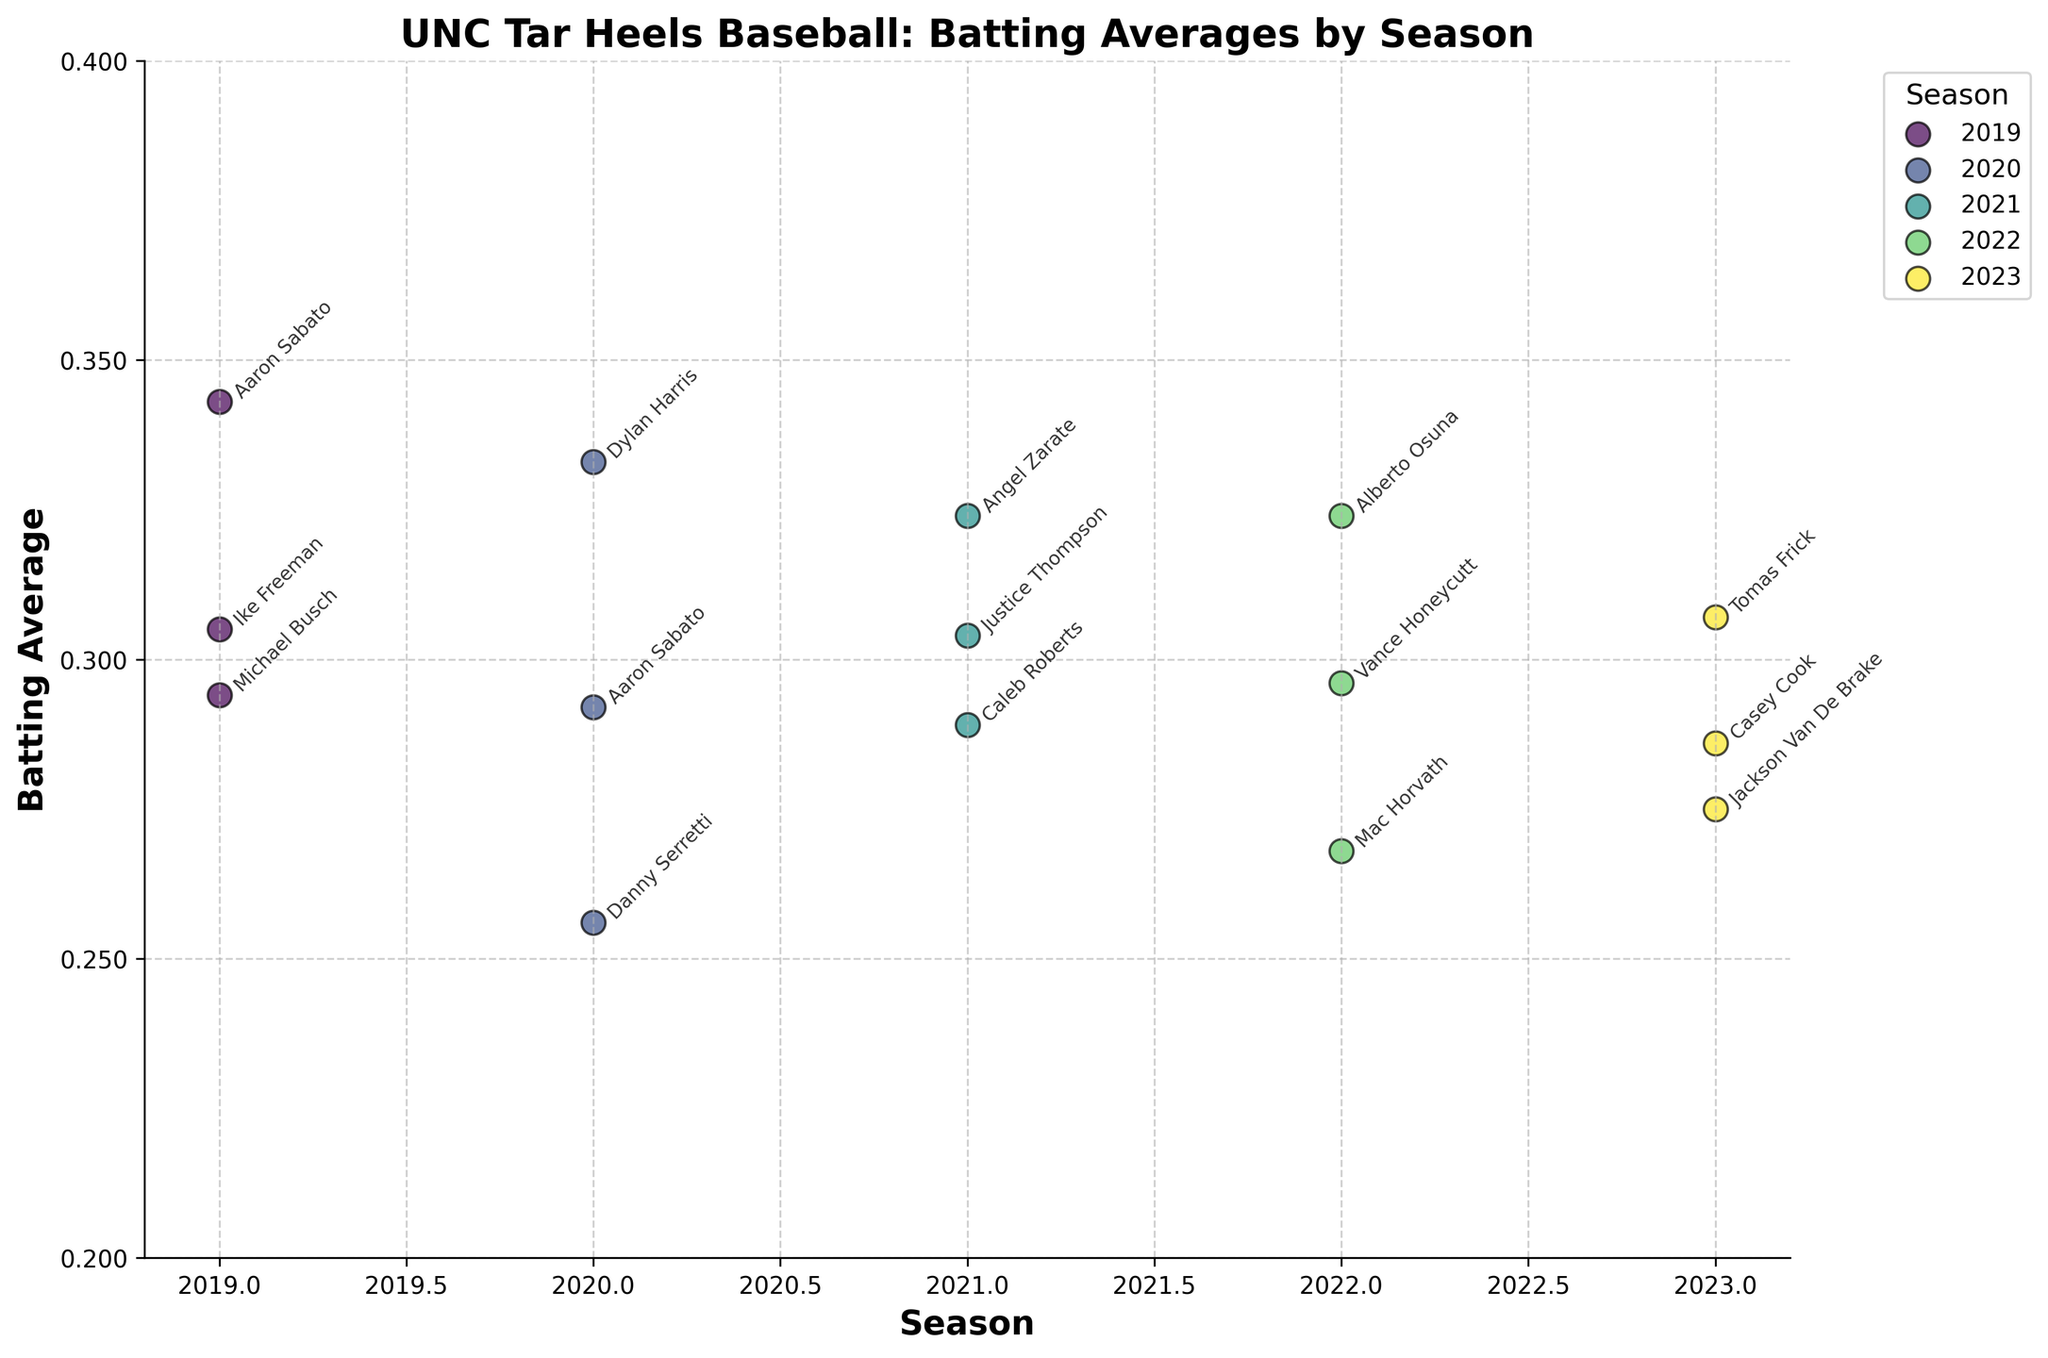What is the title of the plot? The plot title is usually placed at the top of the figure. By looking there, one can see the full title text.
Answer: UNC Tar Heels Baseball: Batting Averages by Season Which season has the highest batting average and which player achieved it? By looking at the y-axis, you identify the highest data points in each season. The highest point overall is in the 2019 season with a batting average of 0.343 achieved by Aaron Sabato.
Answer: 2019, Aaron Sabato What is the range of batting averages shown on the y-axis? Evaluate the limits on the y-axis to determine the minimum and maximum values represented in the plot. The y-axis ranges from 0.2 to 0.4.
Answer: 0.2 to 0.4 Which players had a batting average of over 0.300 in the 2021 season? Locate the 2021 season on the x-axis and check the corresponding data points on the y-axis. The players with averages over 0.300 are Justice Thompson (0.304) and Angel Zarate (0.324).
Answer: Justice Thompson, Angel Zarate How does Aaron Sabato's batting average compare between 2019 and 2020? Locate Aaron Sabato’s data points in the 2019 and 2020 seasons and compare the y-values. In 2019, his average was 0.343, while in 2020 it was 0.292, indicating a decrease.
Answer: Decreased Which player in the 2023 season had the lowest batting average and what was it? Check the data points for the 2023 season on the x-axis and identify the lowest point. Jackson Van De Brake had the lowest batting average of 0.275.
Answer: Jackson Van De Brake, 0.275 What is the average batting average of all players in the 2019 season? Sum the batting averages of all players in the 2019 season and divide by the number of players. (0.294 + 0.343 + 0.305) / 3 = 0.314.
Answer: 0.314 Compare the median batting averages of players between the 2020 and 2022 seasons. Which season had a higher median? List the batting averages for each season, sort them, and find the median value. For 2020: 0.256, 0.292, 0.333 (median = 0.292). For 2022: 0.268, 0.296, 0.324 (median = 0.296). 2022 has the higher median.
Answer: 2022 How many players had a batting average between 0.25 and 0.3 in the 2021 season? Locate the 2021 season on the x-axis and count the data points between 0.25 and 0.3 on the y-axis. Caleb Roberts had a batting average of 0.289, therefore there’s 1 player.
Answer: 1 